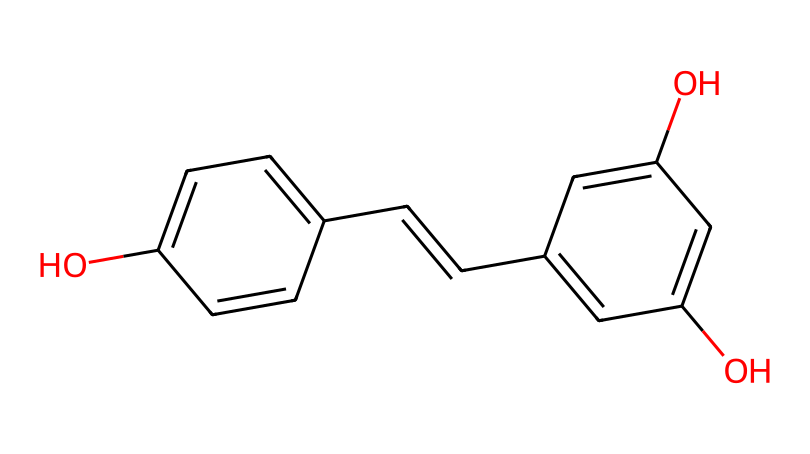What is the common name for this chemical? The SMILES representation corresponds to resveratrol, which is a well-known antioxidant found in red wine.
Answer: resveratrol How many hydroxyl groups are present in the structure? Counting the -OH (hydroxyl) groups in the structure, there are three hydroxyl groups attached to the benzene rings.
Answer: three What is the total number of carbon atoms in this chemical? By analyzing the structure, we count a total of 14 carbon atoms: 10 from the two aromatic rings and 4 from the ethylene bridge.
Answer: fourteen Which part of the structure indicates it has antioxidant properties? The presence of multiple hydroxyl groups in the benzene rings is typical for antioxidants, which help in scavenging free radicals.
Answer: hydroxyl groups How many double bonds are present in the chemical structure? The SMILES notation shows one double bond in the ethylene part of the compound, which is likely between C=C.
Answer: one What type of bond connects the two aromatic rings in the molecule? The molecule features a double bond (C=C) as a connecting structure between the two aromatic rings.
Answer: double bond Does this chemical contain any trans or cis double bonds? By examining the position of the substituents around the double bond, we can conclude that it exhibits a trans configuration.
Answer: trans 